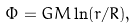<formula> <loc_0><loc_0><loc_500><loc_500>\Phi = G M \ln ( r / R ) ,</formula> 